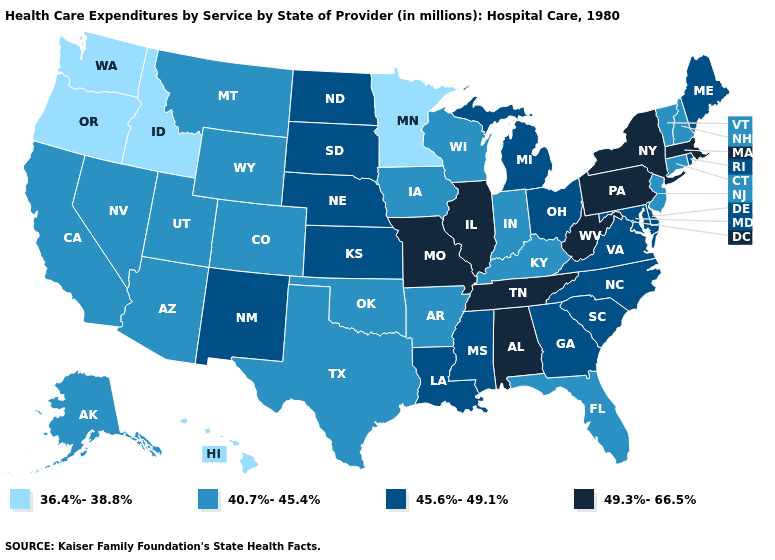What is the highest value in the West ?
Answer briefly. 45.6%-49.1%. Name the states that have a value in the range 40.7%-45.4%?
Be succinct. Alaska, Arizona, Arkansas, California, Colorado, Connecticut, Florida, Indiana, Iowa, Kentucky, Montana, Nevada, New Hampshire, New Jersey, Oklahoma, Texas, Utah, Vermont, Wisconsin, Wyoming. Name the states that have a value in the range 36.4%-38.8%?
Answer briefly. Hawaii, Idaho, Minnesota, Oregon, Washington. Among the states that border Minnesota , does North Dakota have the highest value?
Quick response, please. Yes. Does Nebraska have the highest value in the MidWest?
Concise answer only. No. Does Washington have the lowest value in the West?
Quick response, please. Yes. Does Maine have the same value as Missouri?
Concise answer only. No. What is the value of Arkansas?
Keep it brief. 40.7%-45.4%. Name the states that have a value in the range 45.6%-49.1%?
Be succinct. Delaware, Georgia, Kansas, Louisiana, Maine, Maryland, Michigan, Mississippi, Nebraska, New Mexico, North Carolina, North Dakota, Ohio, Rhode Island, South Carolina, South Dakota, Virginia. What is the highest value in states that border Pennsylvania?
Quick response, please. 49.3%-66.5%. What is the value of Colorado?
Keep it brief. 40.7%-45.4%. Does Washington have a lower value than Massachusetts?
Concise answer only. Yes. Does Oklahoma have a higher value than Illinois?
Quick response, please. No. Among the states that border Oregon , which have the highest value?
Short answer required. California, Nevada. 